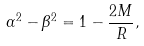<formula> <loc_0><loc_0><loc_500><loc_500>\alpha ^ { 2 } - \beta ^ { 2 } = 1 - \frac { 2 M } { R } ,</formula> 